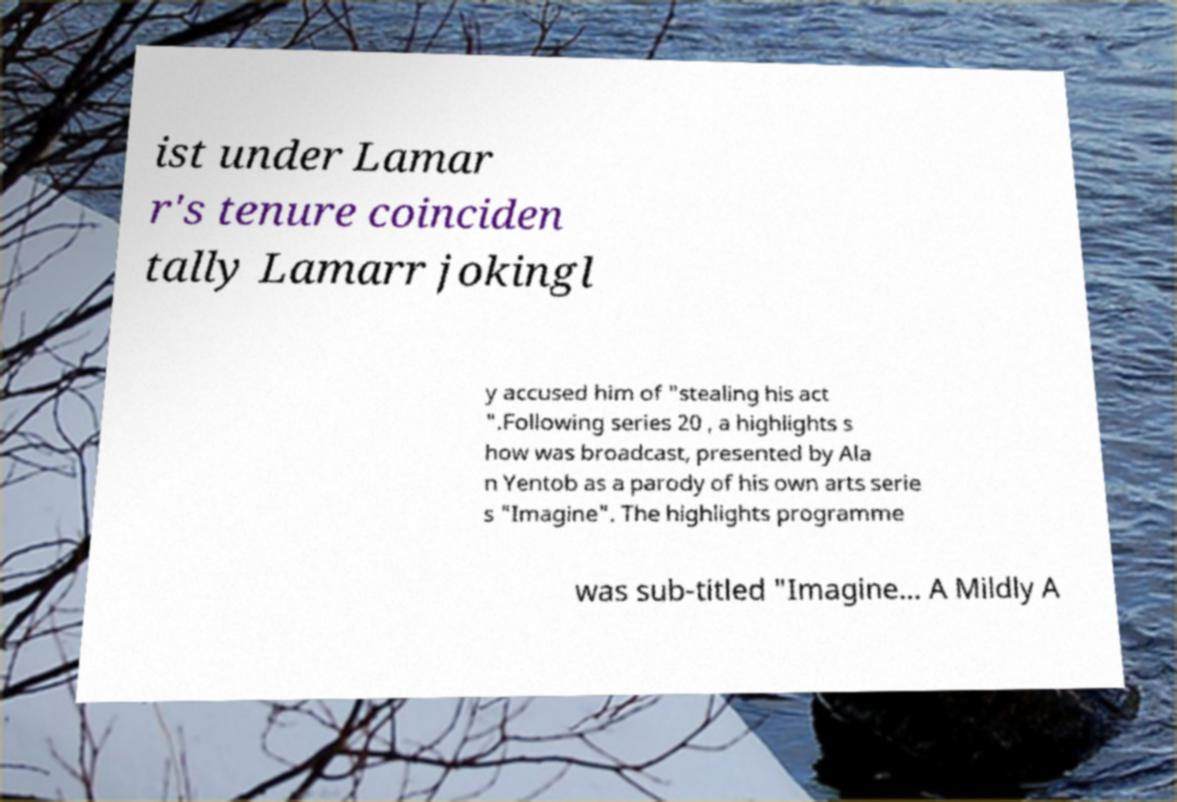There's text embedded in this image that I need extracted. Can you transcribe it verbatim? ist under Lamar r's tenure coinciden tally Lamarr jokingl y accused him of "stealing his act ".Following series 20 , a highlights s how was broadcast, presented by Ala n Yentob as a parody of his own arts serie s "Imagine". The highlights programme was sub-titled "Imagine… A Mildly A 